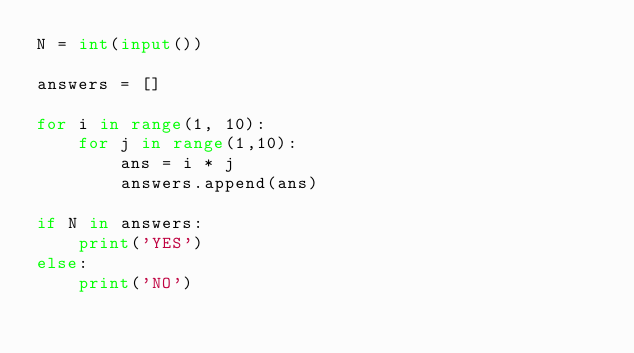<code> <loc_0><loc_0><loc_500><loc_500><_Python_>N = int(input())

answers = []

for i in range(1, 10):
    for j in range(1,10):
        ans = i * j
        answers.append(ans)

if N in answers:
    print('YES')
else:
    print('NO')</code> 